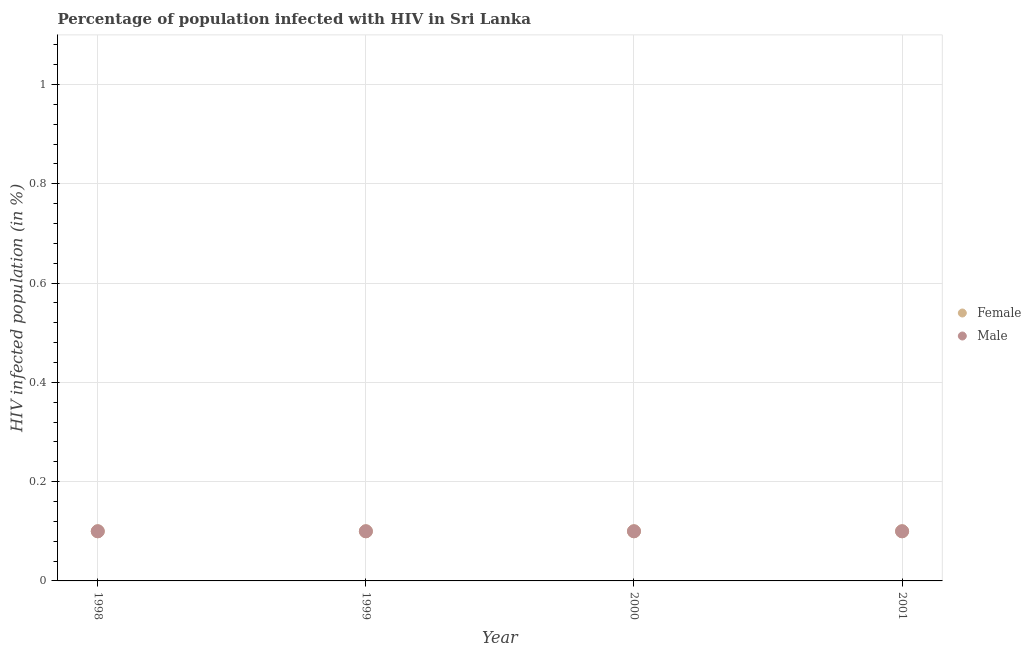Is the number of dotlines equal to the number of legend labels?
Keep it short and to the point. Yes. What is the percentage of females who are infected with hiv in 1998?
Make the answer very short. 0.1. Across all years, what is the maximum percentage of females who are infected with hiv?
Your answer should be very brief. 0.1. In which year was the percentage of males who are infected with hiv maximum?
Give a very brief answer. 1998. In which year was the percentage of males who are infected with hiv minimum?
Keep it short and to the point. 1998. What is the total percentage of females who are infected with hiv in the graph?
Offer a very short reply. 0.4. What is the difference between the percentage of females who are infected with hiv in 2000 and that in 2001?
Your answer should be very brief. 0. What is the difference between the percentage of males who are infected with hiv in 2001 and the percentage of females who are infected with hiv in 2000?
Keep it short and to the point. 0. In the year 2000, what is the difference between the percentage of males who are infected with hiv and percentage of females who are infected with hiv?
Your response must be concise. 0. Is the sum of the percentage of males who are infected with hiv in 1998 and 2001 greater than the maximum percentage of females who are infected with hiv across all years?
Provide a short and direct response. Yes. Does the percentage of males who are infected with hiv monotonically increase over the years?
Your response must be concise. No. Is the percentage of males who are infected with hiv strictly less than the percentage of females who are infected with hiv over the years?
Make the answer very short. No. How many dotlines are there?
Offer a very short reply. 2. Does the graph contain grids?
Your answer should be compact. Yes. Where does the legend appear in the graph?
Offer a terse response. Center right. How many legend labels are there?
Offer a very short reply. 2. How are the legend labels stacked?
Your response must be concise. Vertical. What is the title of the graph?
Give a very brief answer. Percentage of population infected with HIV in Sri Lanka. What is the label or title of the Y-axis?
Keep it short and to the point. HIV infected population (in %). What is the HIV infected population (in %) of Female in 1998?
Your response must be concise. 0.1. What is the HIV infected population (in %) in Male in 1998?
Your response must be concise. 0.1. What is the HIV infected population (in %) in Male in 1999?
Make the answer very short. 0.1. What is the HIV infected population (in %) of Female in 2001?
Make the answer very short. 0.1. Across all years, what is the maximum HIV infected population (in %) in Female?
Provide a succinct answer. 0.1. Across all years, what is the minimum HIV infected population (in %) in Male?
Ensure brevity in your answer.  0.1. What is the total HIV infected population (in %) in Female in the graph?
Offer a very short reply. 0.4. What is the difference between the HIV infected population (in %) in Female in 1998 and that in 1999?
Offer a terse response. 0. What is the difference between the HIV infected population (in %) in Female in 1998 and that in 2000?
Ensure brevity in your answer.  0. What is the difference between the HIV infected population (in %) of Male in 1998 and that in 2001?
Provide a short and direct response. 0. What is the difference between the HIV infected population (in %) of Male in 1999 and that in 2000?
Ensure brevity in your answer.  0. What is the difference between the HIV infected population (in %) of Female in 2000 and that in 2001?
Give a very brief answer. 0. What is the difference between the HIV infected population (in %) of Female in 1998 and the HIV infected population (in %) of Male in 2001?
Provide a short and direct response. 0. What is the difference between the HIV infected population (in %) in Female in 1999 and the HIV infected population (in %) in Male in 2000?
Give a very brief answer. 0. What is the average HIV infected population (in %) of Female per year?
Provide a succinct answer. 0.1. In the year 1999, what is the difference between the HIV infected population (in %) of Female and HIV infected population (in %) of Male?
Offer a very short reply. 0. In the year 2001, what is the difference between the HIV infected population (in %) of Female and HIV infected population (in %) of Male?
Your answer should be very brief. 0. What is the ratio of the HIV infected population (in %) of Male in 1998 to that in 1999?
Ensure brevity in your answer.  1. What is the ratio of the HIV infected population (in %) of Female in 1998 to that in 2000?
Offer a very short reply. 1. What is the ratio of the HIV infected population (in %) in Female in 1998 to that in 2001?
Make the answer very short. 1. What is the ratio of the HIV infected population (in %) in Female in 1999 to that in 2000?
Ensure brevity in your answer.  1. What is the ratio of the HIV infected population (in %) of Male in 1999 to that in 2000?
Your response must be concise. 1. What is the ratio of the HIV infected population (in %) of Female in 2000 to that in 2001?
Offer a very short reply. 1. What is the ratio of the HIV infected population (in %) in Male in 2000 to that in 2001?
Your response must be concise. 1. What is the difference between the highest and the second highest HIV infected population (in %) of Female?
Offer a very short reply. 0. What is the difference between the highest and the second highest HIV infected population (in %) in Male?
Ensure brevity in your answer.  0. What is the difference between the highest and the lowest HIV infected population (in %) of Male?
Make the answer very short. 0. 